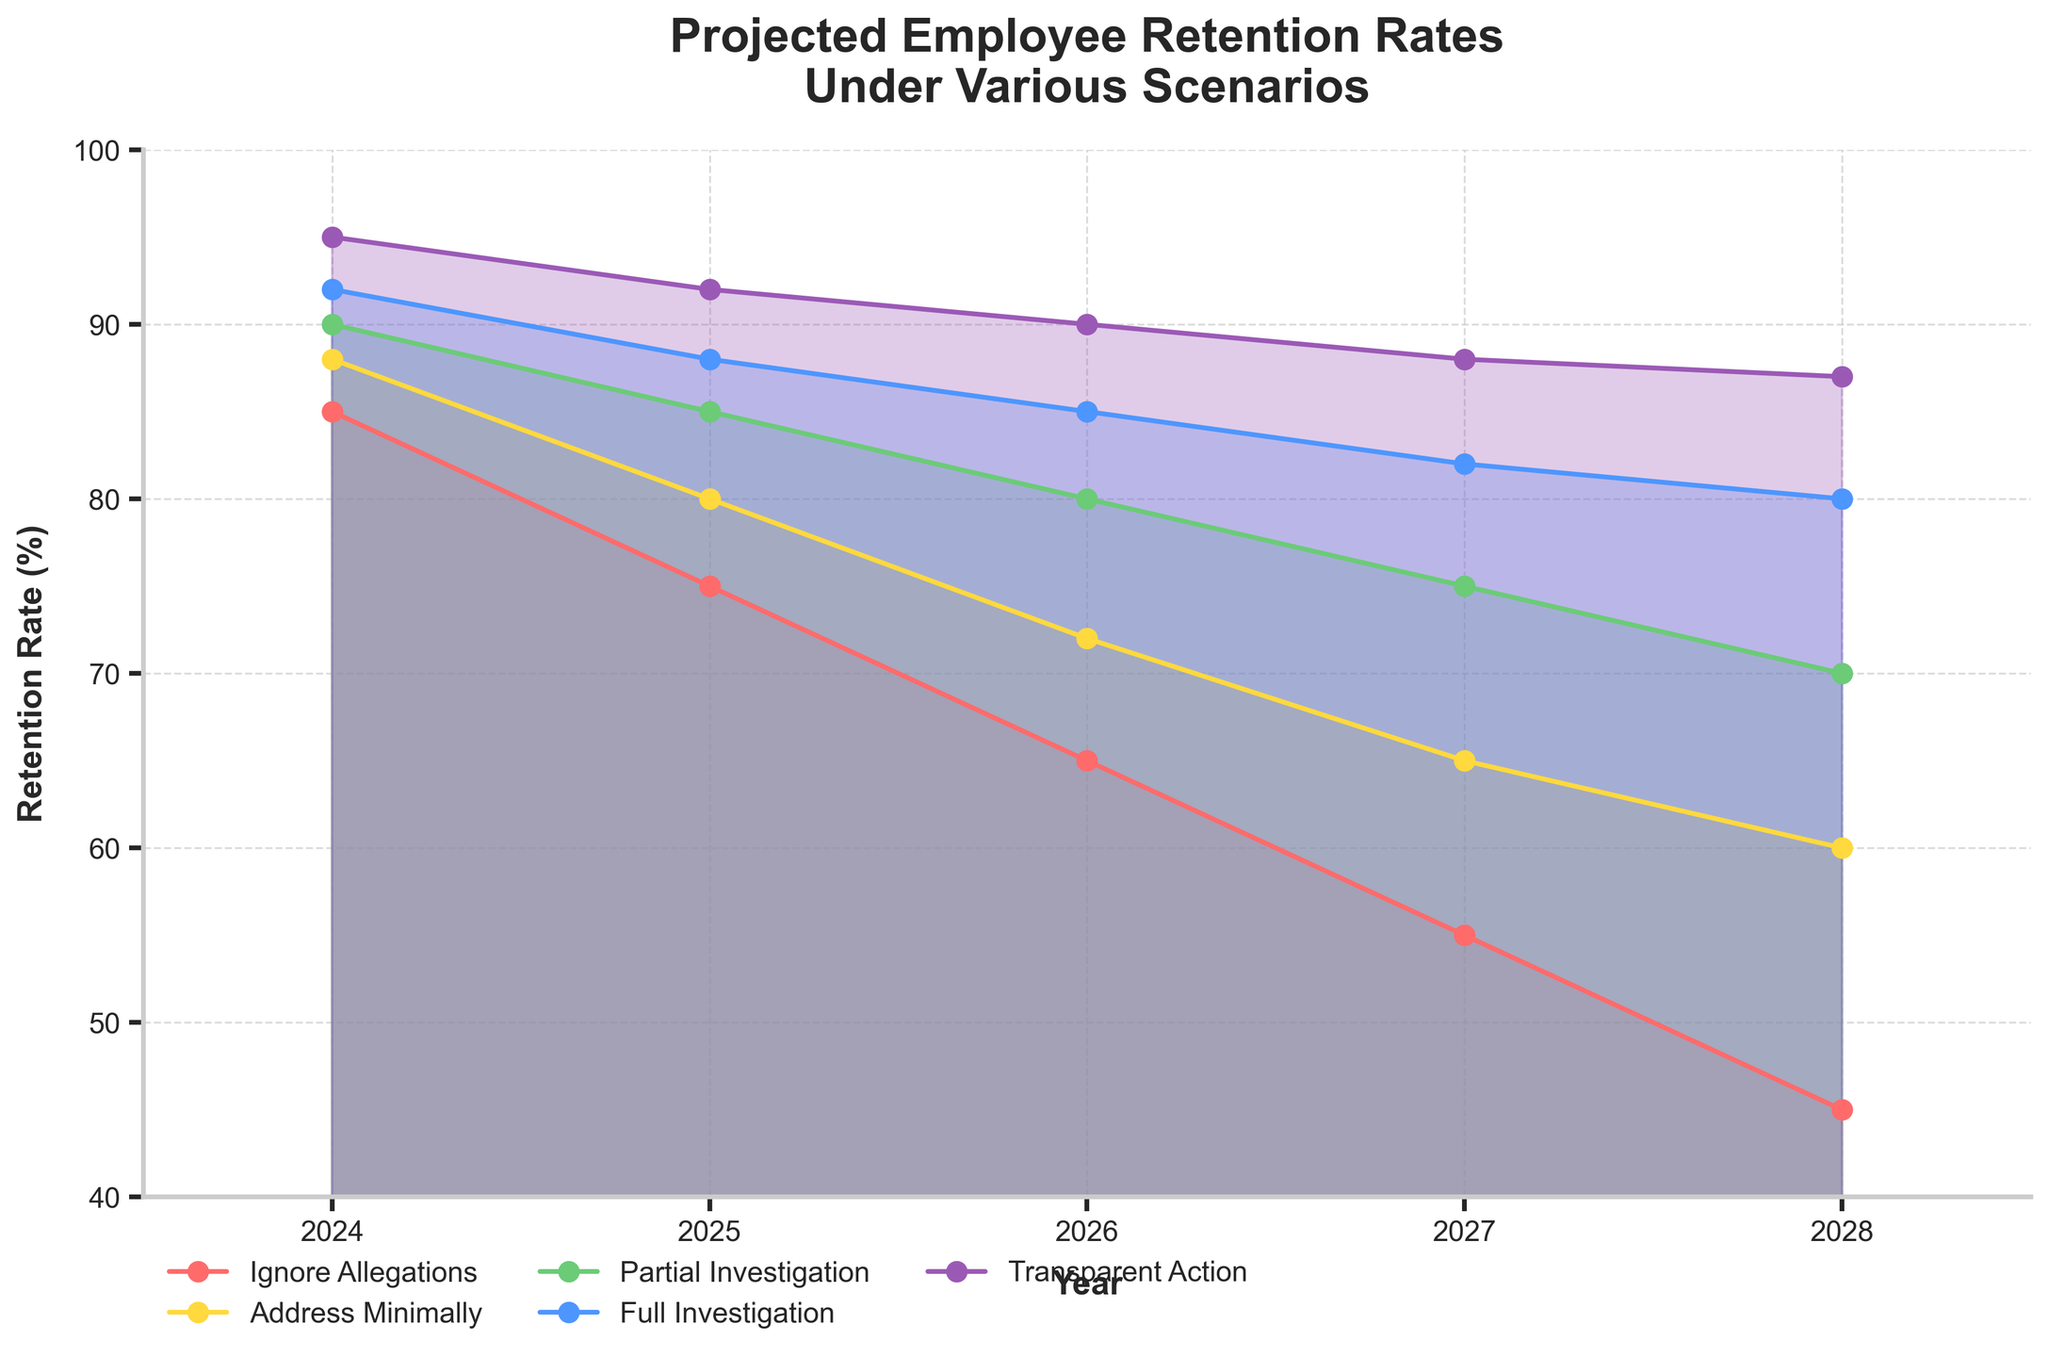How many different scenarios are represented in the figure? The figure includes five distinct scenarios, each represented by different colors and labels: "Ignore Allegations," "Address Minimally," "Partial Investigation," "Full Investigation," and "Transparent Action."
Answer: Five What year is projected to have the highest retention rate under the "Transparent Action" scenario? Looking at the plot, the retention rate under the "Transparent Action" scenario is highest in 2024, with a rate of 95%.
Answer: 2024 Between which years do we see the most significant decline in retention rate for the "Ignore Allegations" scenario? The "Ignore Allegations" scenario shows the most pronounced decline in retention rate between 2024 and 2025, from 85% to 75%.
Answer: 2024 to 2025 What is the retention rate in 2026 for the "Full Investigation" scenario? Referencing the plot, the retention rate in 2026 for the "Full Investigation" scenario is 85%.
Answer: 85% Which scenario maintains a retention rate above 80% for the longest period? The "Transparent Action" scenario maintains a retention rate above 80% for the entire period from 2024 to 2028.
Answer: Transparent Action How does the retention rate in 2027 for the "Partial Investigation" scenario compare to that in 2025 for the "Address Minimally" scenario? In 2027, the retention rate for the "Partial Investigation" scenario is 75%, while in 2025, the rate for the "Address Minimally" scenario is 80%, making the retention rate in 2027 for the "Partial Investigation" scenario 5% lower.
Answer: 5% lower What is the average retention rate from 2024 to 2028 for the "Address Minimally" scenario? Sum up the rates (88 + 80 + 72 + 65 + 60) which equals 365, then divide by 5. The average retention rate is 365/5 = 73%.
Answer: 73% If the company chooses the "Ignore Allegations" scenario, what will be the drop in retention rate from 2024 to 2028? The retention rate drops from 85% in 2024 to 45% in 2028 under the "Ignore Allegations" scenario. The drop is 85 - 45 = 40%.
Answer: 40% Which scenario in 2028 has a lower retention rate: "Address Minimally" or "Partial Investigation"? In 2028, the "Address Minimally" scenario has a retention rate of 60%, whereas the "Partial Investigation" scenario has a retention rate of 70%. Thus, "Address Minimally" has a lower rate.
Answer: Address Minimally What is the trend of employee retention rates over time, irrespective of the scenario? The overall trend across all scenarios shows a gradual decline in employee retention rates from 2024 to 2028. Each scenario's retention rate decreases, though at different rates.
Answer: Declining 